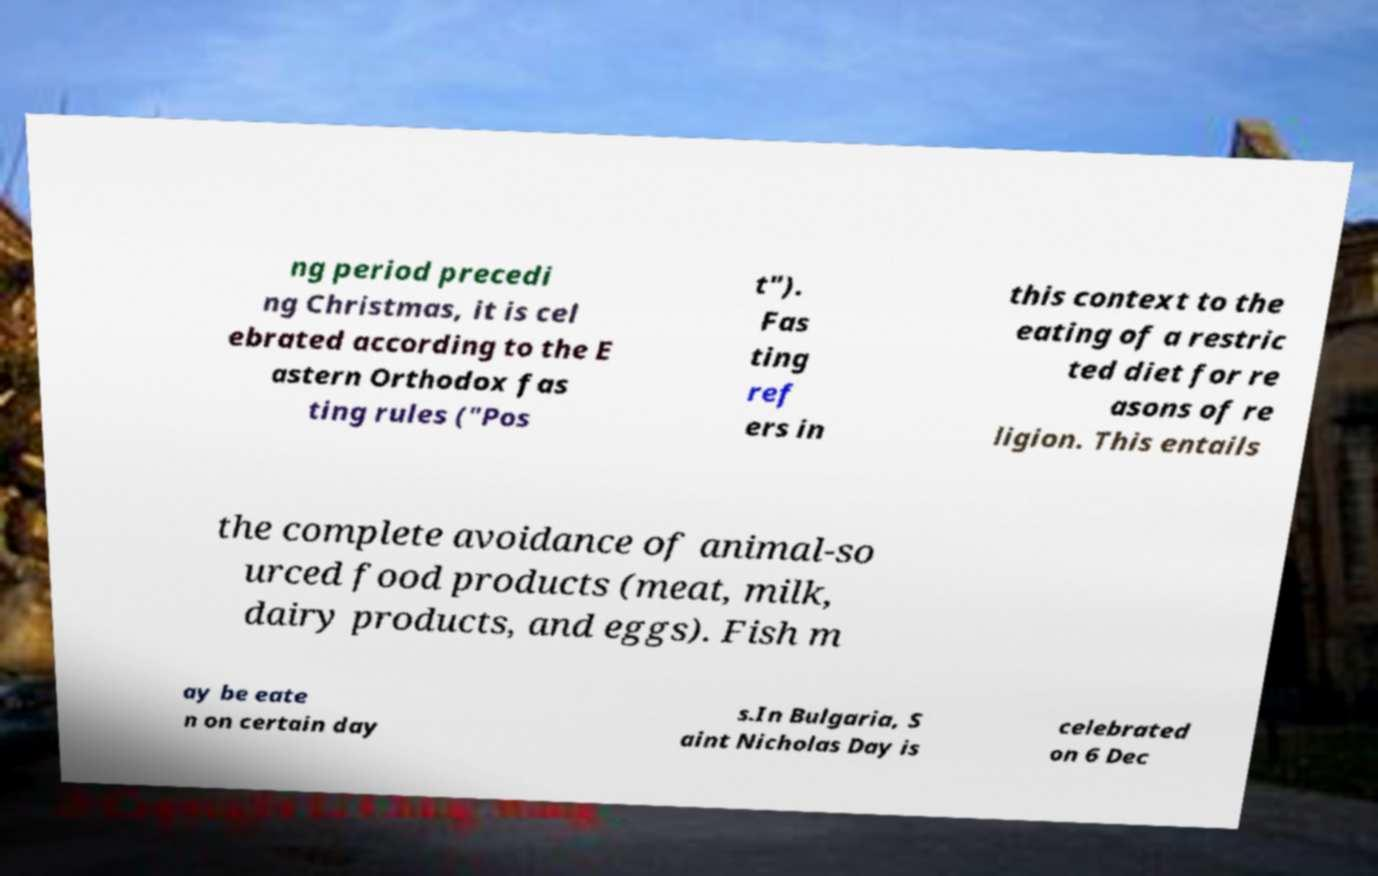Please read and relay the text visible in this image. What does it say? ng period precedi ng Christmas, it is cel ebrated according to the E astern Orthodox fas ting rules ("Pos t"). Fas ting ref ers in this context to the eating of a restric ted diet for re asons of re ligion. This entails the complete avoidance of animal-so urced food products (meat, milk, dairy products, and eggs). Fish m ay be eate n on certain day s.In Bulgaria, S aint Nicholas Day is celebrated on 6 Dec 